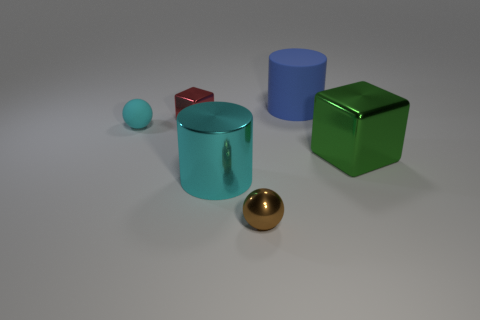There is a cyan metallic object that is left of the blue matte object; what size is it?
Your answer should be compact. Large. Is the number of green shiny blocks that are behind the small metallic block greater than the number of large cyan rubber blocks?
Offer a terse response. No. There is a tiny brown object; what shape is it?
Ensure brevity in your answer.  Sphere. Does the cube that is on the right side of the big blue rubber object have the same color as the big cylinder in front of the green metallic block?
Offer a very short reply. No. Does the blue rubber object have the same shape as the big cyan thing?
Your answer should be compact. Yes. Are there any other things that have the same shape as the green thing?
Give a very brief answer. Yes. Is the cylinder behind the small red shiny cube made of the same material as the brown sphere?
Your response must be concise. No. There is a object that is both on the right side of the cyan cylinder and in front of the large green cube; what shape is it?
Your response must be concise. Sphere. There is a big cylinder that is behind the small red metal object; are there any small red shiny objects behind it?
Offer a very short reply. No. What number of other objects are there of the same material as the small red object?
Your response must be concise. 3. 